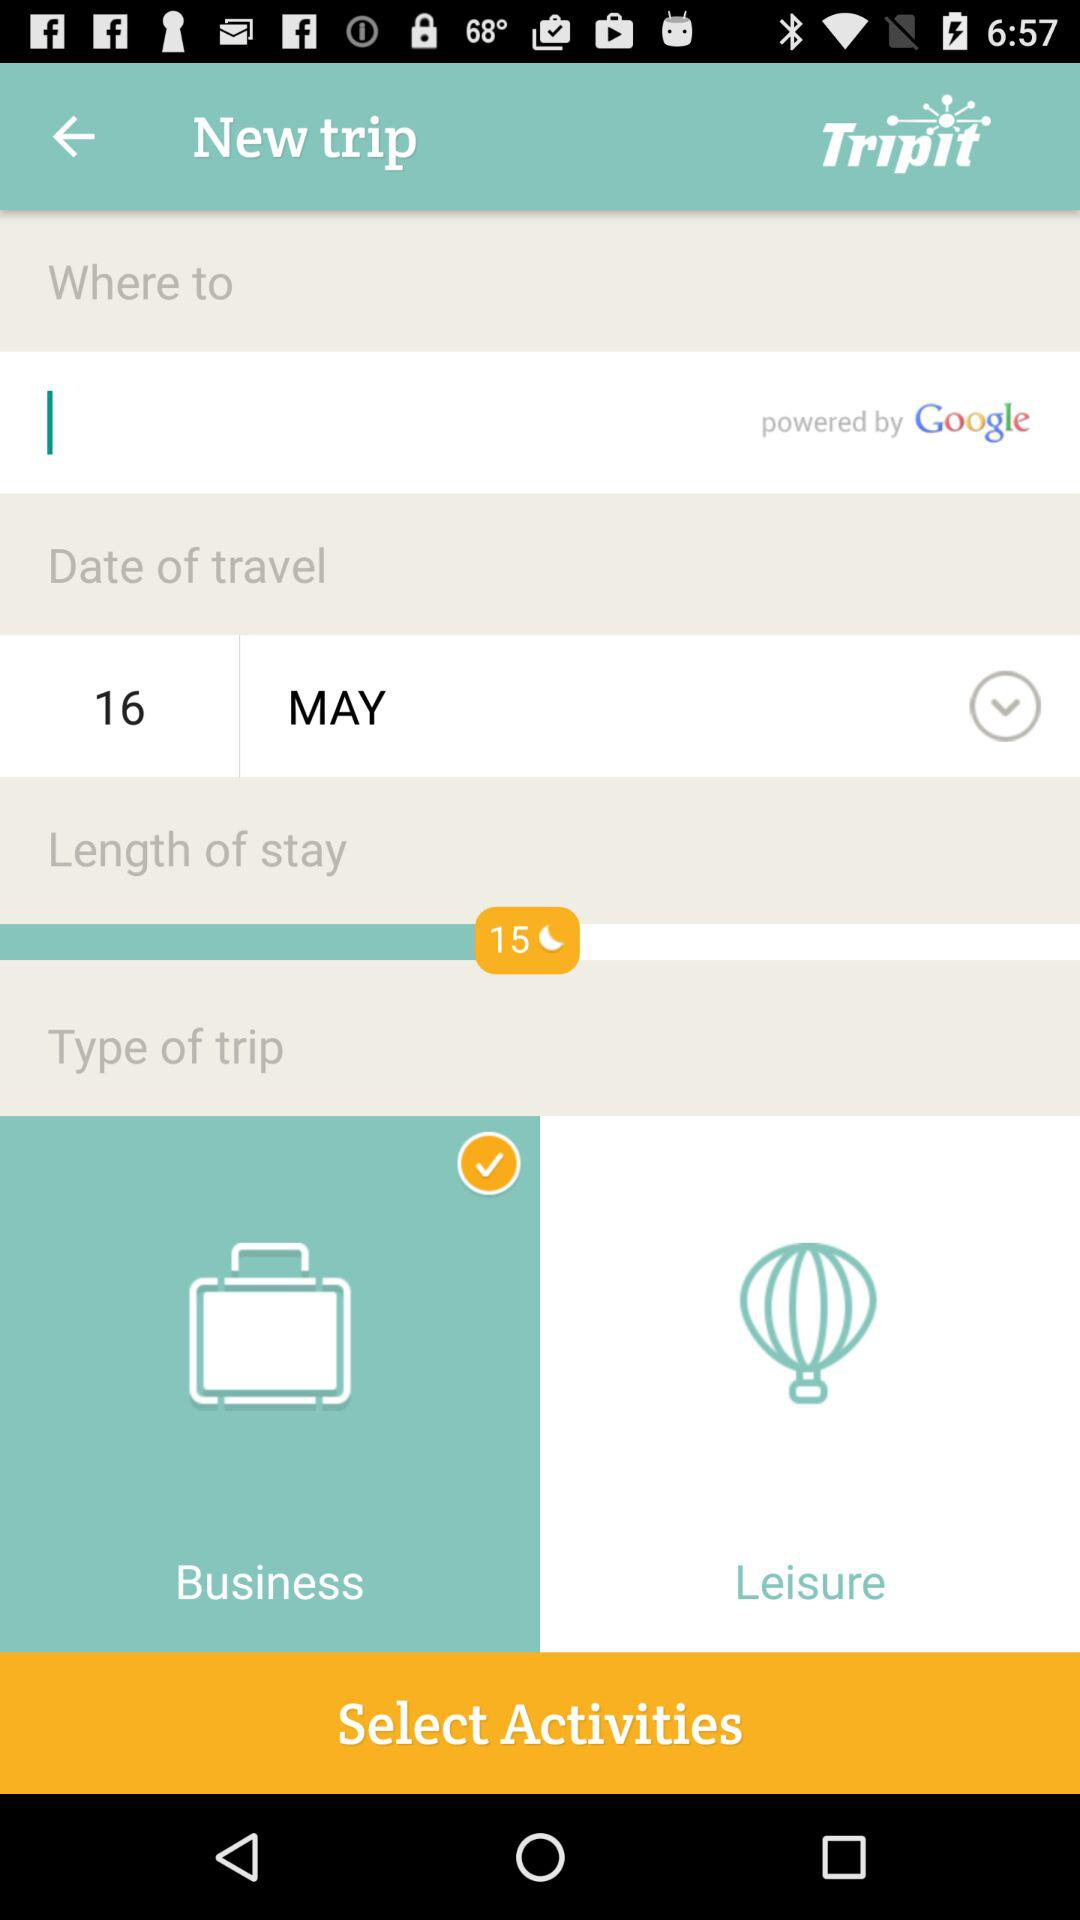What is the name of the application? The name of the application is "Tripit". 